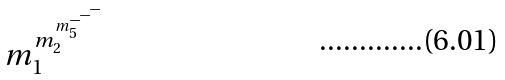Convert formula to latex. <formula><loc_0><loc_0><loc_500><loc_500>m _ { 1 } ^ { m _ { 2 } ^ { m _ { 5 } ^ { - ^ { - ^ { - } } } } }</formula> 